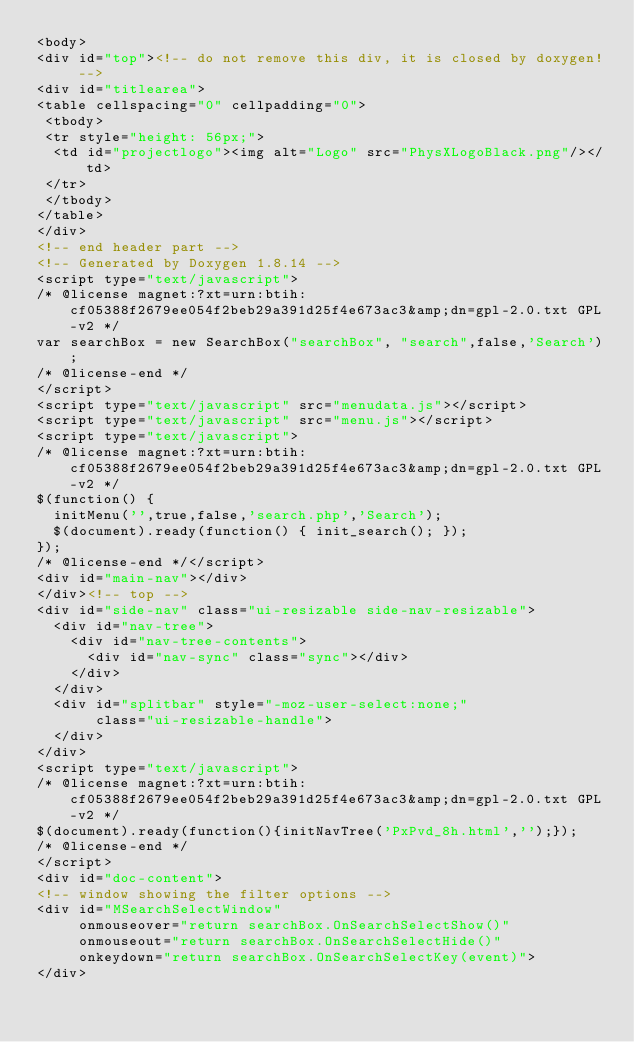<code> <loc_0><loc_0><loc_500><loc_500><_HTML_><body>
<div id="top"><!-- do not remove this div, it is closed by doxygen! -->
<div id="titlearea">
<table cellspacing="0" cellpadding="0">
 <tbody>
 <tr style="height: 56px;">
  <td id="projectlogo"><img alt="Logo" src="PhysXLogoBlack.png"/></td>
 </tr>
 </tbody>
</table>
</div>
<!-- end header part -->
<!-- Generated by Doxygen 1.8.14 -->
<script type="text/javascript">
/* @license magnet:?xt=urn:btih:cf05388f2679ee054f2beb29a391d25f4e673ac3&amp;dn=gpl-2.0.txt GPL-v2 */
var searchBox = new SearchBox("searchBox", "search",false,'Search');
/* @license-end */
</script>
<script type="text/javascript" src="menudata.js"></script>
<script type="text/javascript" src="menu.js"></script>
<script type="text/javascript">
/* @license magnet:?xt=urn:btih:cf05388f2679ee054f2beb29a391d25f4e673ac3&amp;dn=gpl-2.0.txt GPL-v2 */
$(function() {
  initMenu('',true,false,'search.php','Search');
  $(document).ready(function() { init_search(); });
});
/* @license-end */</script>
<div id="main-nav"></div>
</div><!-- top -->
<div id="side-nav" class="ui-resizable side-nav-resizable">
  <div id="nav-tree">
    <div id="nav-tree-contents">
      <div id="nav-sync" class="sync"></div>
    </div>
  </div>
  <div id="splitbar" style="-moz-user-select:none;" 
       class="ui-resizable-handle">
  </div>
</div>
<script type="text/javascript">
/* @license magnet:?xt=urn:btih:cf05388f2679ee054f2beb29a391d25f4e673ac3&amp;dn=gpl-2.0.txt GPL-v2 */
$(document).ready(function(){initNavTree('PxPvd_8h.html','');});
/* @license-end */
</script>
<div id="doc-content">
<!-- window showing the filter options -->
<div id="MSearchSelectWindow"
     onmouseover="return searchBox.OnSearchSelectShow()"
     onmouseout="return searchBox.OnSearchSelectHide()"
     onkeydown="return searchBox.OnSearchSelectKey(event)">
</div>
</code> 